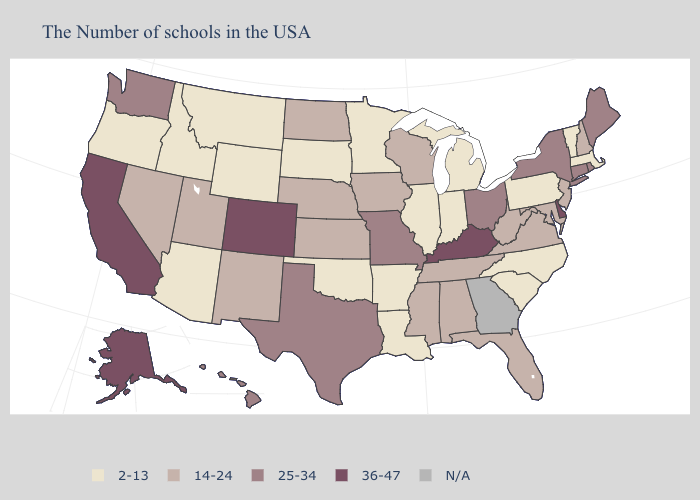Does the first symbol in the legend represent the smallest category?
Short answer required. Yes. Is the legend a continuous bar?
Be succinct. No. Name the states that have a value in the range 36-47?
Give a very brief answer. Delaware, Kentucky, Colorado, California, Alaska. What is the highest value in the MidWest ?
Answer briefly. 25-34. What is the highest value in the MidWest ?
Quick response, please. 25-34. What is the value of Kentucky?
Be succinct. 36-47. Is the legend a continuous bar?
Keep it brief. No. What is the highest value in the USA?
Write a very short answer. 36-47. What is the value of Pennsylvania?
Quick response, please. 2-13. Which states have the lowest value in the USA?
Be succinct. Massachusetts, Vermont, Pennsylvania, North Carolina, South Carolina, Michigan, Indiana, Illinois, Louisiana, Arkansas, Minnesota, Oklahoma, South Dakota, Wyoming, Montana, Arizona, Idaho, Oregon. Does the map have missing data?
Keep it brief. Yes. Does Arkansas have the lowest value in the South?
Write a very short answer. Yes. Is the legend a continuous bar?
Short answer required. No. What is the lowest value in states that border Arizona?
Answer briefly. 14-24. Among the states that border Wyoming , which have the lowest value?
Answer briefly. South Dakota, Montana, Idaho. 